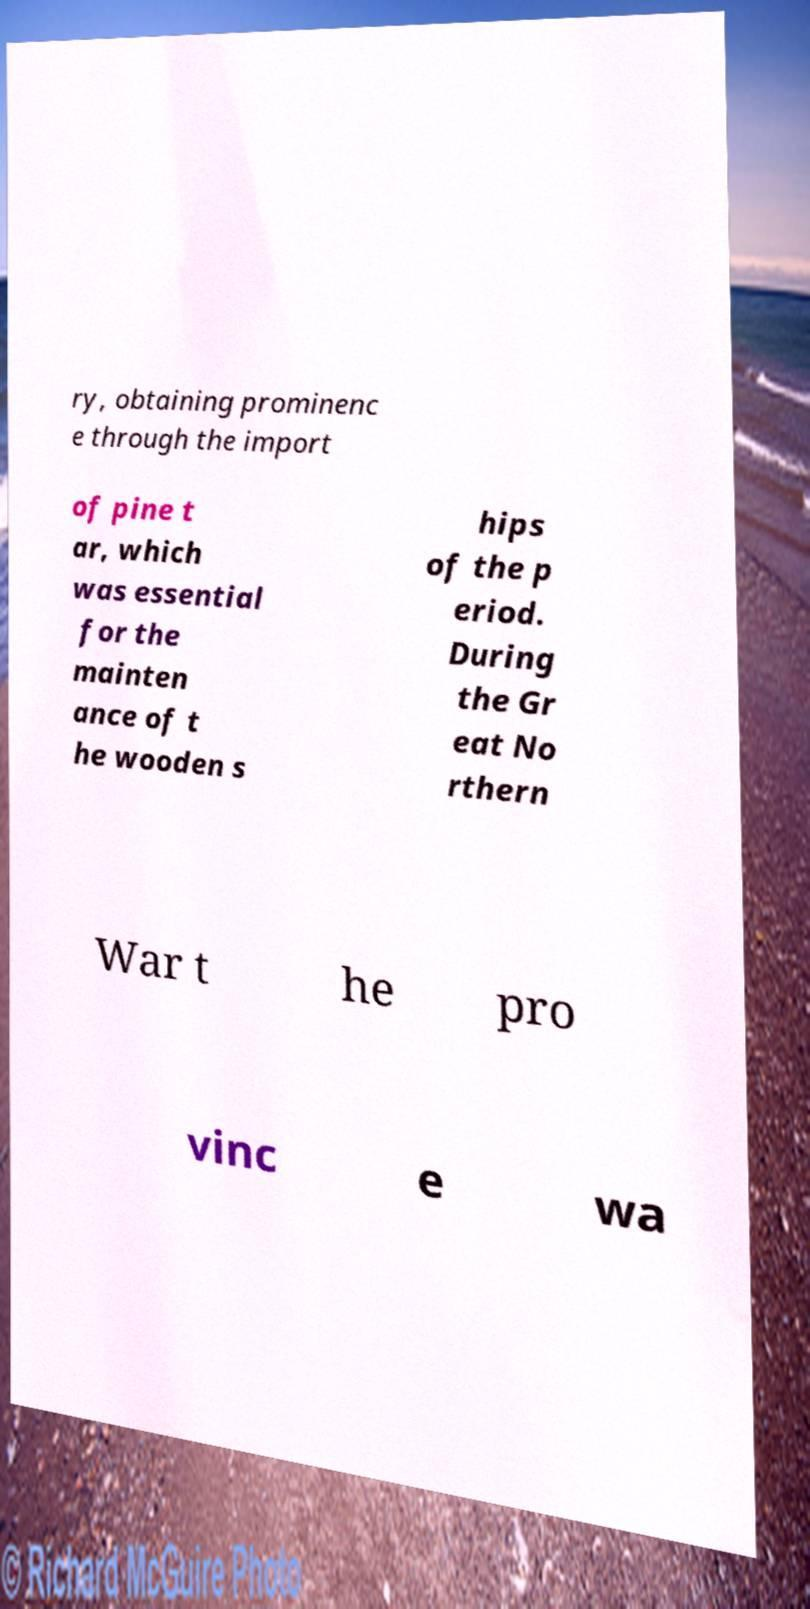For documentation purposes, I need the text within this image transcribed. Could you provide that? ry, obtaining prominenc e through the import of pine t ar, which was essential for the mainten ance of t he wooden s hips of the p eriod. During the Gr eat No rthern War t he pro vinc e wa 